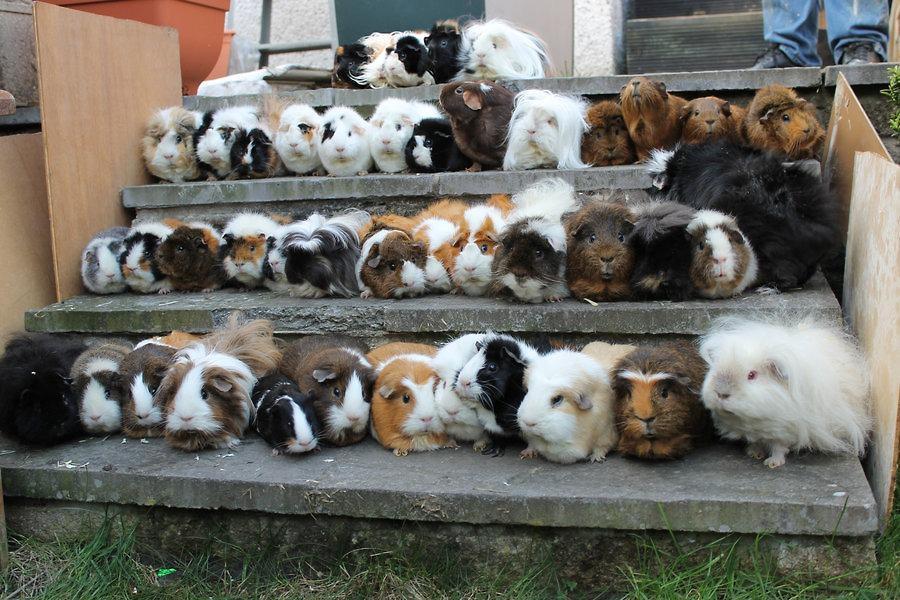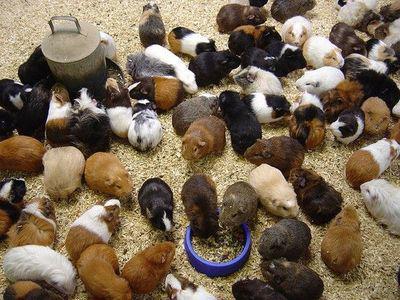The first image is the image on the left, the second image is the image on the right. For the images displayed, is the sentence "Some of the animals are sitting on steps outside." factually correct? Answer yes or no. Yes. The first image is the image on the left, the second image is the image on the right. For the images displayed, is the sentence "An image shows variously colored hamsters arranged in stepped rows." factually correct? Answer yes or no. Yes. 